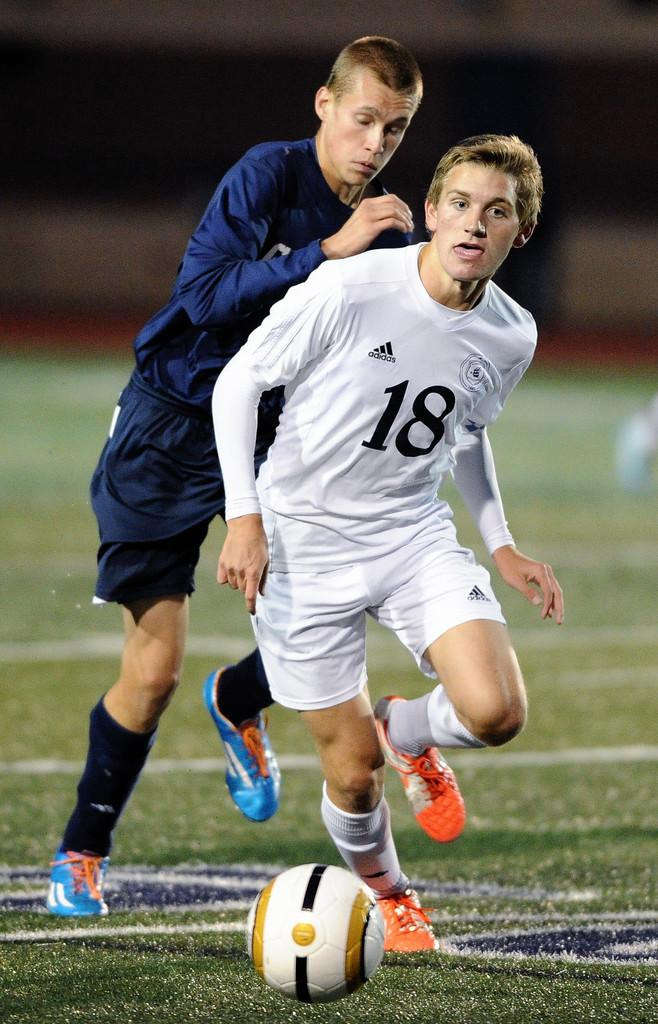How many people are in the image? There are two men in the image. What activity are the two men engaged in? The two men are playing football. Can you describe the background of the image? The background of the image is blurry. What type of scissors can be seen being used by one of the men in the image? There are no scissors present in the image; the two men are playing football. On which side of the field are the two men playing football in the image? The image does not provide enough information to determine on which side of the field the two men are playing football. 